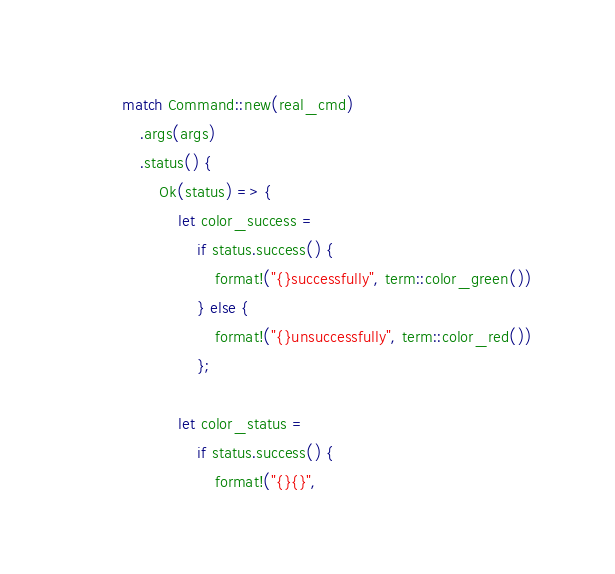<code> <loc_0><loc_0><loc_500><loc_500><_Rust_>        match Command::new(real_cmd)
            .args(args)
            .status() {
                Ok(status) => {
                    let color_success =
                        if status.success() {
                            format!("{}successfully", term::color_green())
                        } else {
                            format!("{}unsuccessfully", term::color_red())
                        };

                    let color_status =
                        if status.success() {
                            format!("{}{}",</code> 